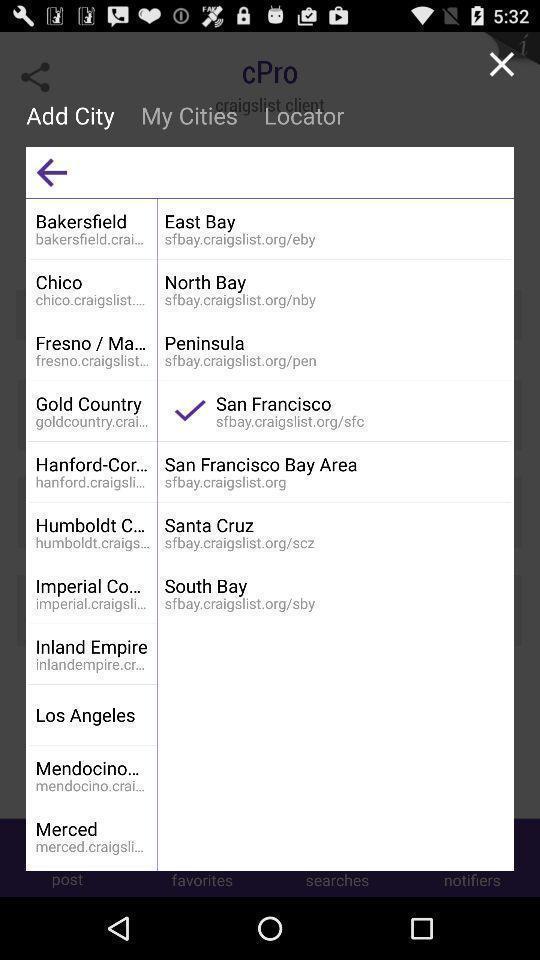Describe the visual elements of this screenshot. Pop-up displaying to select the city. 